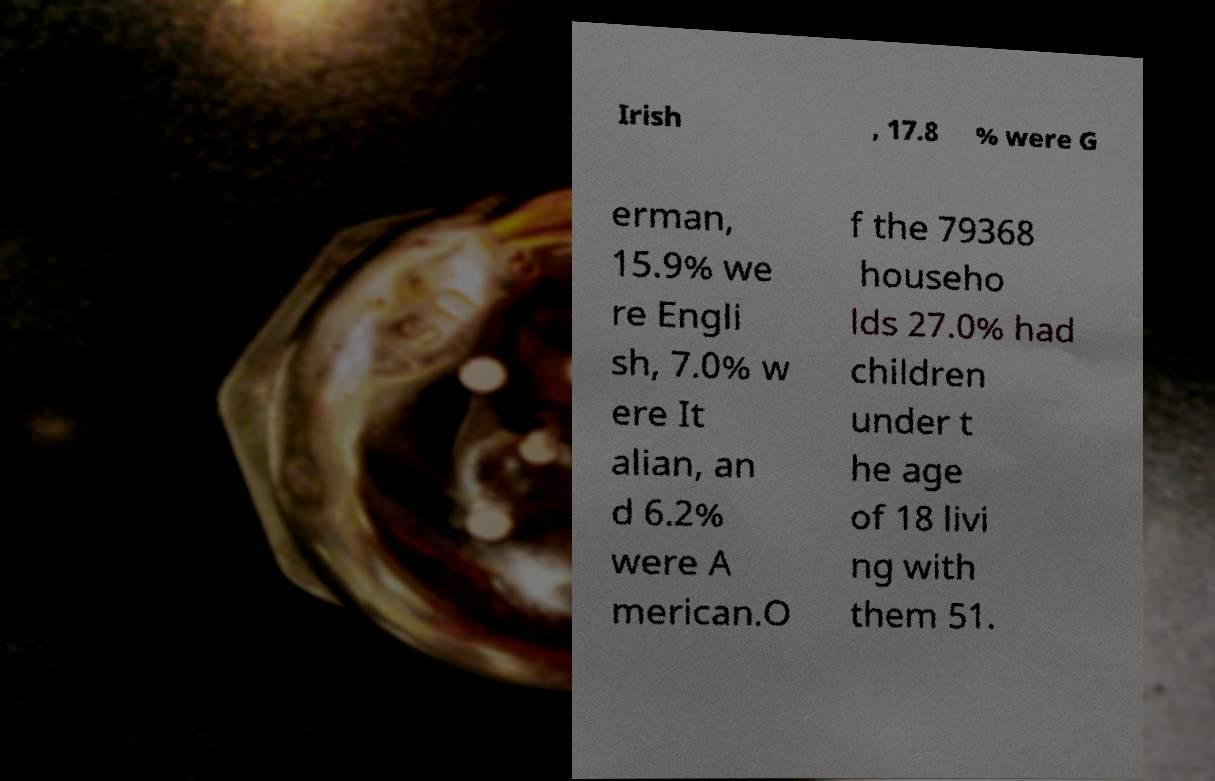There's text embedded in this image that I need extracted. Can you transcribe it verbatim? Irish , 17.8 % were G erman, 15.9% we re Engli sh, 7.0% w ere It alian, an d 6.2% were A merican.O f the 79368 househo lds 27.0% had children under t he age of 18 livi ng with them 51. 